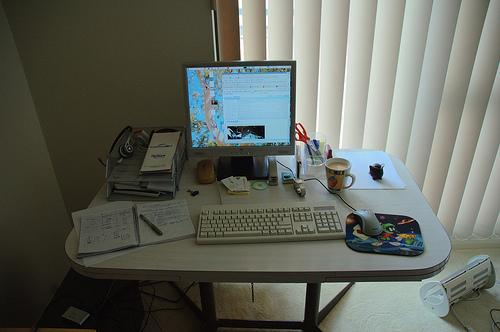Write a concise description of the key elements found in the image, focusing on items found on the table. A computer with a flat screen monitor, wired keyboard and mouse, open notebook with a pen, coffee cup with strawberry design, and cartoon mouse pad with red scissors. Describe the table's content in the image, highlighting any noteworthy details. A computer and its peripherals, a blue mouse pad featuring a cartoon character, open notebook with a pen, a reddish coffee cup with a strawberry, and red scissors with an orange handle. Detail the scene captured in the image, emphasizing the objects on the table. A computer setup with monitor, wired keyboard and mouse, open notebook and black pen, a mug with a strawberry and coffee, a character mouse pad, and orange scissors. Provide a brief description of the primary items on the table in the image. A computer with monitor, keyboard and mouse, an open notebook with a pen on it, a coffee cup, mouse pad with cartoon, and red scissors. Provide a short description of the main objects seen in the picture, focusing on their characteristics. A flat screen monitor with tree wallpaper, wired keyboard and mouse, blue mouse pad with Marvin the Martian, open notebook with pen, a designed coffee cup, and red-orange handled scissors. Create a sentence illustrating the main objects in the photo and their positions on the table. On the table, there is a computer with its peripherals, an open notebook with pen, a coffee cup, a mouse pad with Marvin the Martian, and red scissors with orange handle. Summarize the main objects on the table and any distinguishable features. Computer setup with flat screen monitor, wired peripherals, open notebook with pen resting atop, coffee cup with strawberry, and red-orange scissors. Write a brief summary of the primary objects shown in the image, emphasizing unique attributes. A computer station with wired keyboard and mouse, Marvin the Martian mouse pad, open notebook with black pen, strawberry-adorned coffee cup, and red scissors with orange handle. Mention the key elements in the image along with their unique properties. Flat screen monitor with a tree wallpaper, wired keyboard and mouse, blue mouse pad featuring Marvin the Martian, and orange-handled red scissors. List the primary elements present in the photo, focusing on the computer setup. Flat screen monitor, wired keyboard, wired mouse, mouse pad with cartoon character, open notebook and pen, red scissors, and coffee cup. 